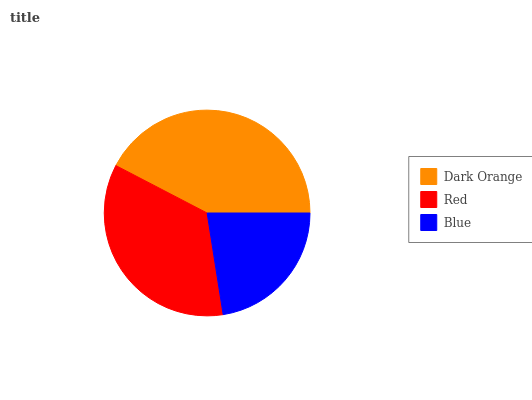Is Blue the minimum?
Answer yes or no. Yes. Is Dark Orange the maximum?
Answer yes or no. Yes. Is Red the minimum?
Answer yes or no. No. Is Red the maximum?
Answer yes or no. No. Is Dark Orange greater than Red?
Answer yes or no. Yes. Is Red less than Dark Orange?
Answer yes or no. Yes. Is Red greater than Dark Orange?
Answer yes or no. No. Is Dark Orange less than Red?
Answer yes or no. No. Is Red the high median?
Answer yes or no. Yes. Is Red the low median?
Answer yes or no. Yes. Is Dark Orange the high median?
Answer yes or no. No. Is Blue the low median?
Answer yes or no. No. 